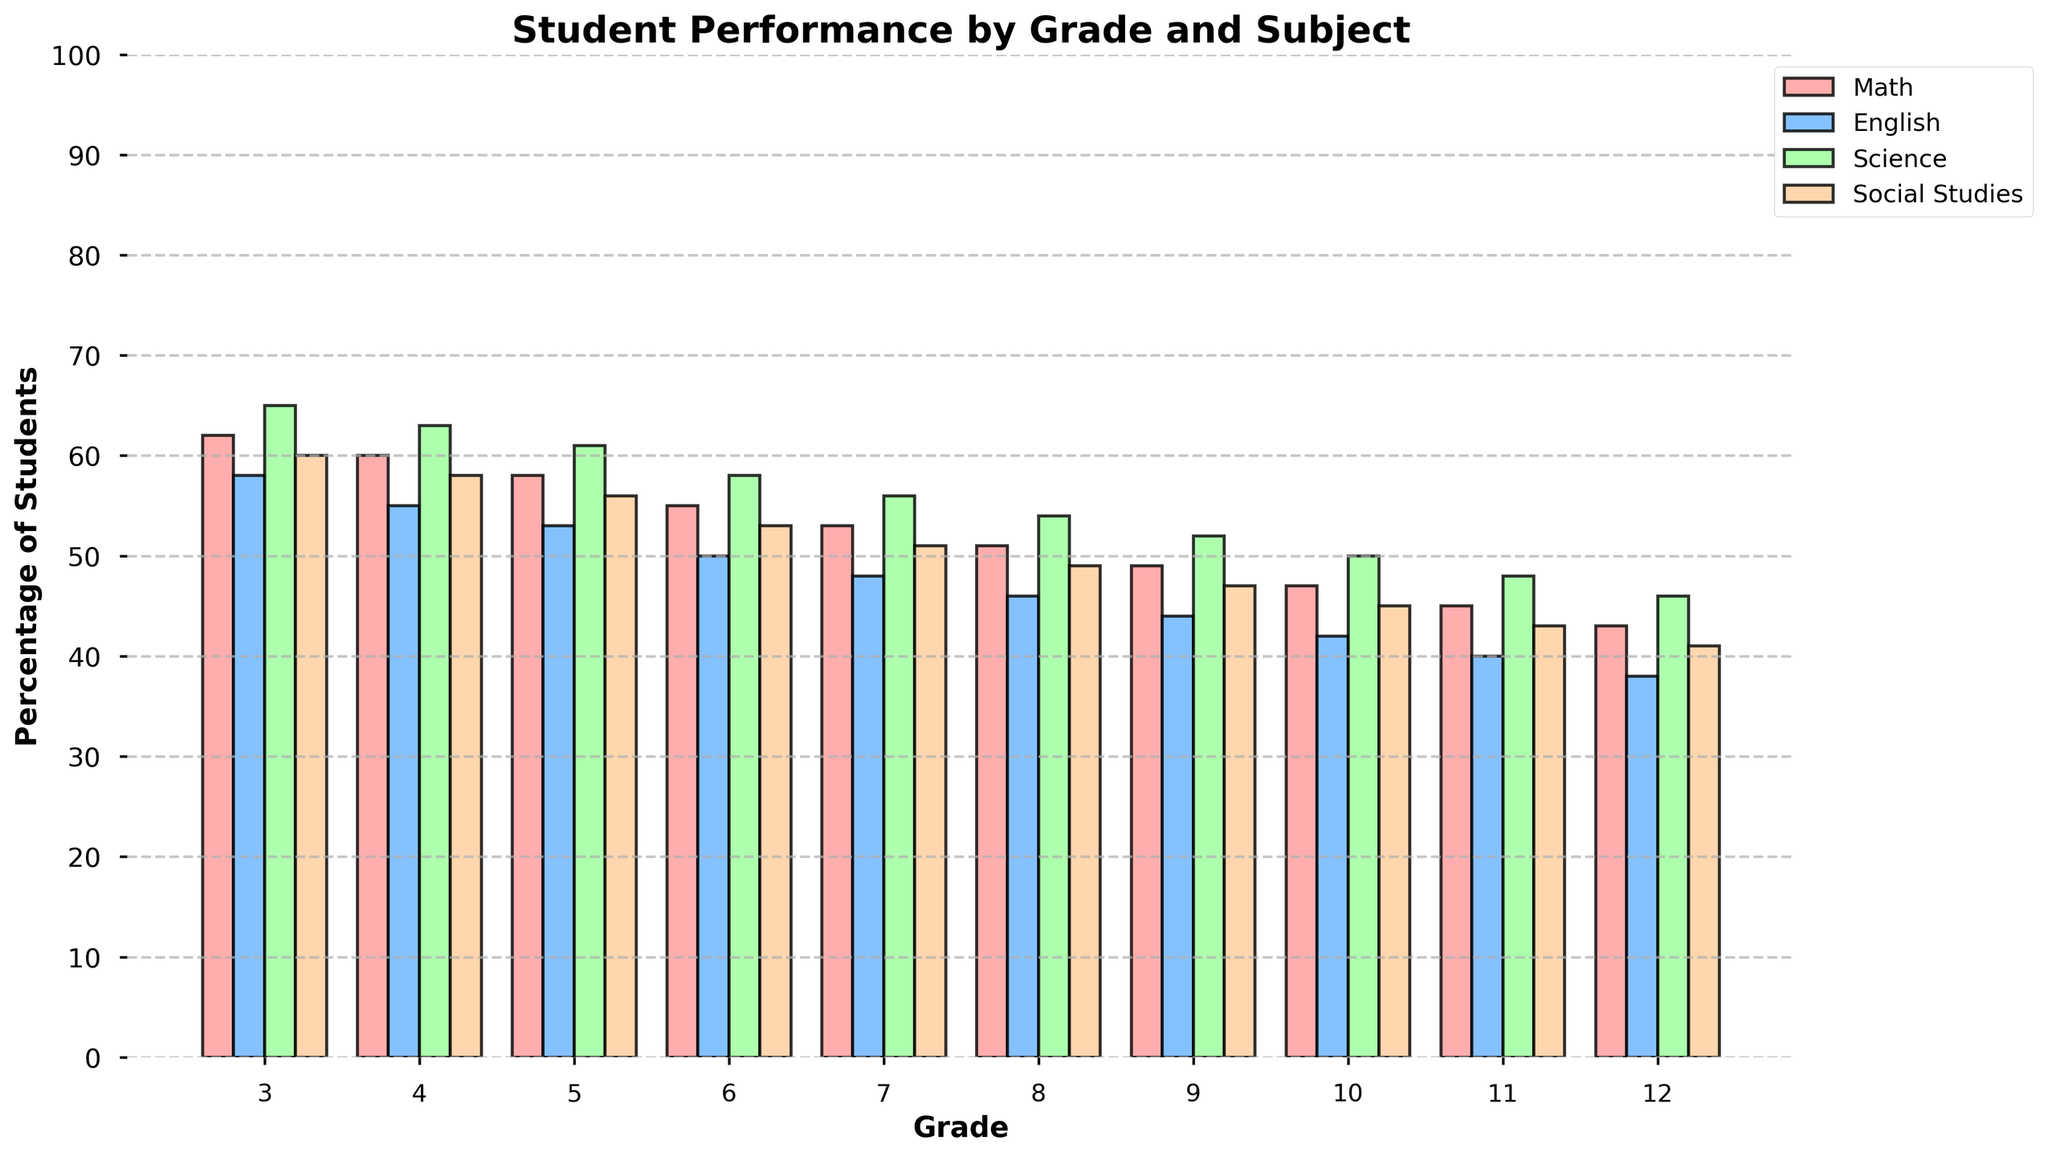What is the percentage of 7th graders meeting or exceeding state standards in Science? Look for the bar labeled "Grade 7" and check the height of the bar corresponding to Science. The Science bar for 7th grade is 56%.
Answer: 56% Which subject has the highest percentage of students meeting or exceeding state standards in 3rd grade? Check the height of the bars for each subject under Grade 3. The tallest bar is Science with 65%.
Answer: Science How does the percentage of students meeting or exceeding state standards in Math change from 3rd grade to 12th grade? Look at the bars corresponding to Math from Grade 3 to Grade 12, note the percentages which decrease from 62% in 3rd grade to 43% in 12th grade. The change is 62% - 43% = 19%.
Answer: Decreases by 19% Which grade shows the smallest difference between the percentages of students meeting or exceeding state standards in Math and English? Look at the height of the Math and English bars for each grade and compute the difference for each one. Grade 10 has Math at 47% and English at 42%, the difference is 5%, which is the smallest difference across all grades.
Answer: 10th Grade In which subject does the percentage of students meeting or exceeding state standards drop the most between 5th grade and 8th grade? Calculate the difference for each subject from 5th grade to 8th grade. For Math (58%-51%=7%), English (53%-46%=7%), Science (61%-54%=7%), and Social Studies (56%-49%=7%). All subjects experience the same drop of 7%, so the drop is uniform.
Answer: All subjects What is the average percentage of students meeting or exceeding state standards across all subjects in 3rd grade? Sum the percentages for each subject in 3rd grade (Math 62%, English 58%, Science 65%, Social Studies 60%) and divide by the number of subjects. Calculated as (62% + 58% + 65% + 60%) / 4 = 61.25%.
Answer: 61.25% Which grade and subject combination has the lowest percentage of students meeting or exceeding state standards? Look for the shortest bar in the graph for each grade and subject combination. The shortest bar is for English in 12th grade at 38%.
Answer: 12th Grade English Compare the percentage of students meeting or exceeding state standards in Math and Science for 6th grade. Which is higher and by how much? Look at the bars for Math and Science in 6th grade. Math is 55% and Science is 58%. The difference is 58% - 55% = 3%. Science is higher by 3%.
Answer: Science by 3% What is the trend in the percentage of students meeting or exceeding state standards in Social Studies from 3rd grade to 12th grade? Observe the height of the bars for Social Studies from 3rd grade to 12th grade, the percentages decrease from 60% to 41%, showing a downward trend.
Answer: Downward trend Which grade has the highest overall average percentage of students meeting or exceeding state standards across all subjects? Calculate the average percentage for each grade by summing up the results for each subject and dividing by 4. Grade 3: (62+58+65+60)/4 = 61.25%, Grade 4: (60+55+63+58)/4 = 59%, Grade 5: (58+53+61+56)/4 = 57%, Grade 6: (55+50+58+53)/4 = 54%, Grade 7: (53+48+56+51)/4 = 52%, Grade 8: (51+46+54+49)/4 = 50%, Grade 9: (49+44+52+47)/4 = 48%, Grade 10: (47+42+50+45)/4 = 46%, Grade 11: (45+40+48+43)/4 = 44%, Grade 12: (43+38+46+41)/4 = 42%. The highest average is in Grade 3 with 61.25%.
Answer: 3rd Grade 